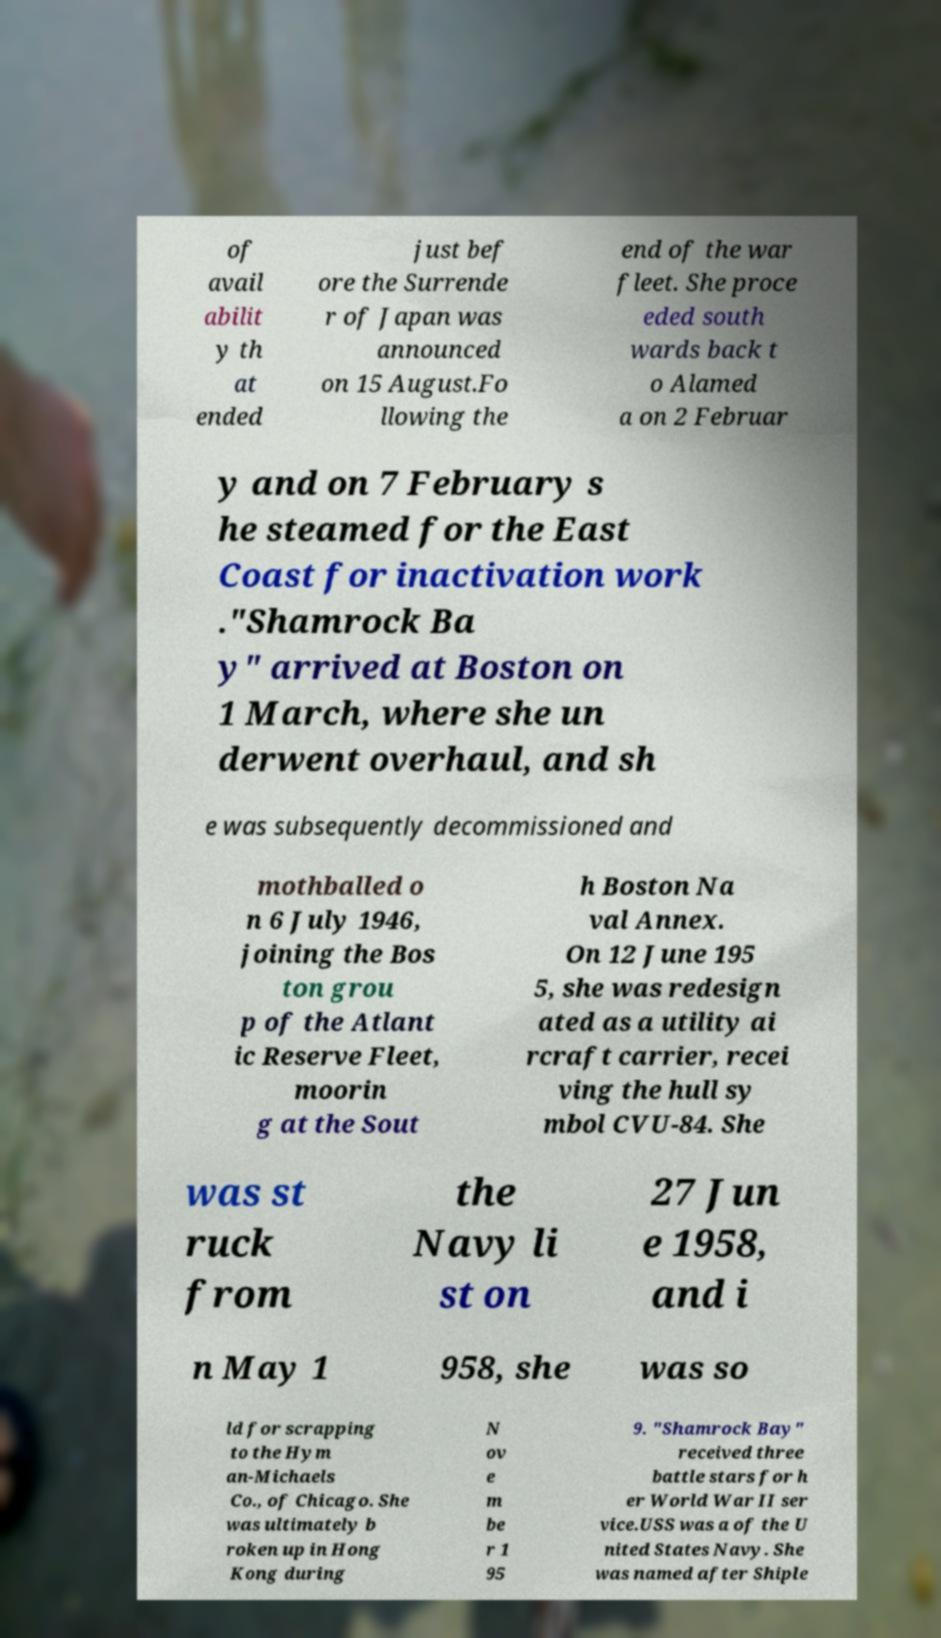Could you extract and type out the text from this image? of avail abilit y th at ended just bef ore the Surrende r of Japan was announced on 15 August.Fo llowing the end of the war fleet. She proce eded south wards back t o Alamed a on 2 Februar y and on 7 February s he steamed for the East Coast for inactivation work ."Shamrock Ba y" arrived at Boston on 1 March, where she un derwent overhaul, and sh e was subsequently decommissioned and mothballed o n 6 July 1946, joining the Bos ton grou p of the Atlant ic Reserve Fleet, moorin g at the Sout h Boston Na val Annex. On 12 June 195 5, she was redesign ated as a utility ai rcraft carrier, recei ving the hull sy mbol CVU-84. She was st ruck from the Navy li st on 27 Jun e 1958, and i n May 1 958, she was so ld for scrapping to the Hym an-Michaels Co., of Chicago. She was ultimately b roken up in Hong Kong during N ov e m be r 1 95 9. "Shamrock Bay" received three battle stars for h er World War II ser vice.USS was a of the U nited States Navy. She was named after Shiple 